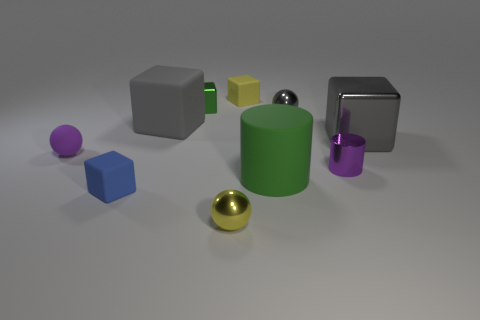Subtract all large gray blocks. How many blocks are left? 3 Subtract all gray cubes. How many cubes are left? 3 Subtract 3 cubes. How many cubes are left? 2 Subtract all blue cubes. Subtract all red balls. How many cubes are left? 4 Subtract all spheres. How many objects are left? 7 Add 6 yellow blocks. How many yellow blocks exist? 7 Subtract 0 gray cylinders. How many objects are left? 10 Subtract all gray rubber things. Subtract all large green matte cylinders. How many objects are left? 8 Add 9 small cylinders. How many small cylinders are left? 10 